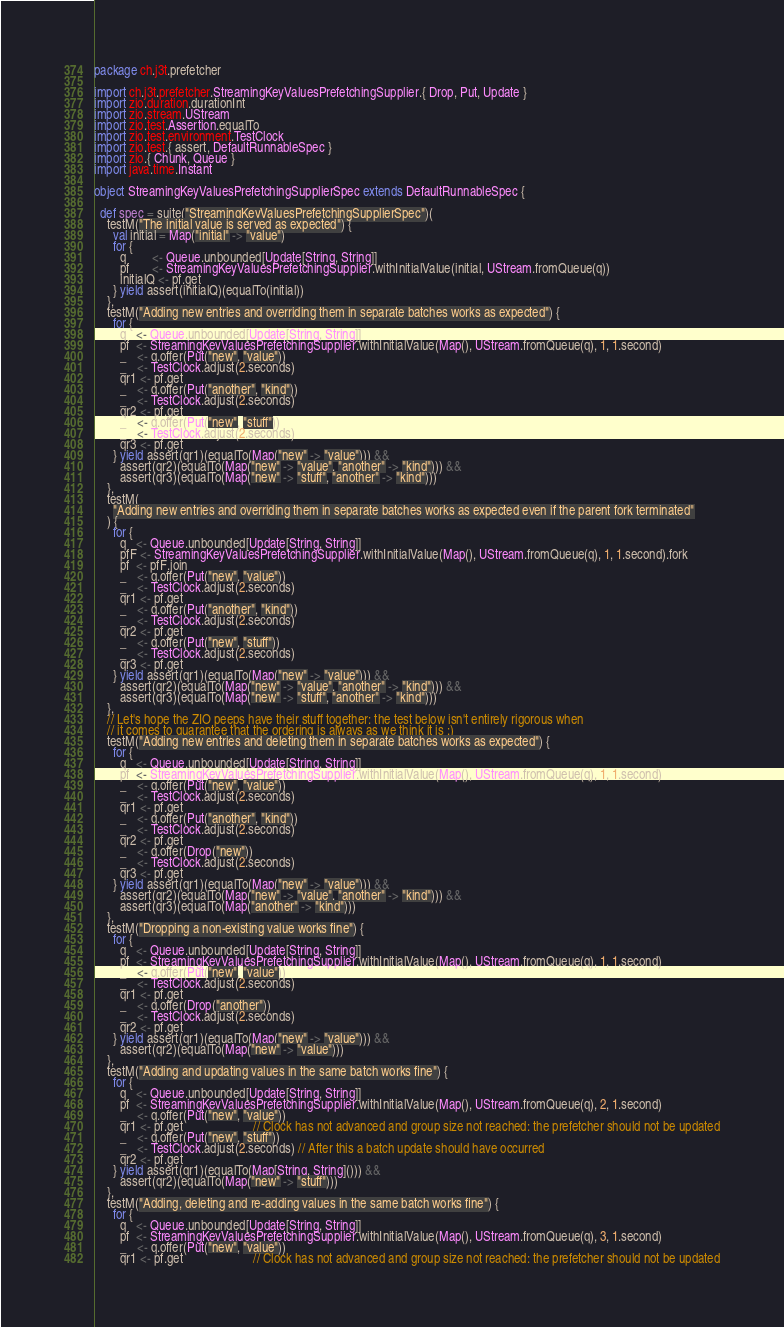Convert code to text. <code><loc_0><loc_0><loc_500><loc_500><_Scala_>package ch.j3t.prefetcher

import ch.j3t.prefetcher.StreamingKeyValuesPrefetchingSupplier.{ Drop, Put, Update }
import zio.duration.durationInt
import zio.stream.UStream
import zio.test.Assertion.equalTo
import zio.test.environment.TestClock
import zio.test.{ assert, DefaultRunnableSpec }
import zio.{ Chunk, Queue }
import java.time.Instant

object StreamingKeyValuesPrefetchingSupplierSpec extends DefaultRunnableSpec {

  def spec = suite("StreamingKeyValuesPrefetchingSupplierSpec")(
    testM("The initial value is served as expected") {
      val initial = Map("initial" -> "value")
      for {
        q        <- Queue.unbounded[Update[String, String]]
        pf       <- StreamingKeyValuesPrefetchingSupplier.withInitialValue(initial, UStream.fromQueue(q))
        initialQ <- pf.get
      } yield assert(initialQ)(equalTo(initial))
    },
    testM("Adding new entries and overriding them in separate batches works as expected") {
      for {
        q   <- Queue.unbounded[Update[String, String]]
        pf  <- StreamingKeyValuesPrefetchingSupplier.withInitialValue(Map(), UStream.fromQueue(q), 1, 1.second)
        _   <- q.offer(Put("new", "value"))
        _   <- TestClock.adjust(2.seconds)
        qr1 <- pf.get
        _   <- q.offer(Put("another", "kind"))
        _   <- TestClock.adjust(2.seconds)
        qr2 <- pf.get
        _   <- q.offer(Put("new", "stuff"))
        _   <- TestClock.adjust(2.seconds)
        qr3 <- pf.get
      } yield assert(qr1)(equalTo(Map("new" -> "value"))) &&
        assert(qr2)(equalTo(Map("new" -> "value", "another" -> "kind"))) &&
        assert(qr3)(equalTo(Map("new" -> "stuff", "another" -> "kind")))
    },
    testM(
      "Adding new entries and overriding them in separate batches works as expected even if the parent fork terminated"
    ) {
      for {
        q   <- Queue.unbounded[Update[String, String]]
        pfF <- StreamingKeyValuesPrefetchingSupplier.withInitialValue(Map(), UStream.fromQueue(q), 1, 1.second).fork
        pf  <- pfF.join
        _   <- q.offer(Put("new", "value"))
        _   <- TestClock.adjust(2.seconds)
        qr1 <- pf.get
        _   <- q.offer(Put("another", "kind"))
        _   <- TestClock.adjust(2.seconds)
        qr2 <- pf.get
        _   <- q.offer(Put("new", "stuff"))
        _   <- TestClock.adjust(2.seconds)
        qr3 <- pf.get
      } yield assert(qr1)(equalTo(Map("new" -> "value"))) &&
        assert(qr2)(equalTo(Map("new" -> "value", "another" -> "kind"))) &&
        assert(qr3)(equalTo(Map("new" -> "stuff", "another" -> "kind")))
    },
    // Let's hope the ZIO peeps have their stuff together: the test below isn't entirely rigorous when
    // it comes to guarantee that the ordering is always as we think it is ;)
    testM("Adding new entries and deleting them in separate batches works as expected") {
      for {
        q   <- Queue.unbounded[Update[String, String]]
        pf  <- StreamingKeyValuesPrefetchingSupplier.withInitialValue(Map(), UStream.fromQueue(q), 1, 1.second)
        _   <- q.offer(Put("new", "value"))
        _   <- TestClock.adjust(2.seconds)
        qr1 <- pf.get
        _   <- q.offer(Put("another", "kind"))
        _   <- TestClock.adjust(2.seconds)
        qr2 <- pf.get
        _   <- q.offer(Drop("new"))
        _   <- TestClock.adjust(2.seconds)
        qr3 <- pf.get
      } yield assert(qr1)(equalTo(Map("new" -> "value"))) &&
        assert(qr2)(equalTo(Map("new" -> "value", "another" -> "kind"))) &&
        assert(qr3)(equalTo(Map("another" -> "kind")))
    },
    testM("Dropping a non-existing value works fine") {
      for {
        q   <- Queue.unbounded[Update[String, String]]
        pf  <- StreamingKeyValuesPrefetchingSupplier.withInitialValue(Map(), UStream.fromQueue(q), 1, 1.second)
        _   <- q.offer(Put("new", "value"))
        _   <- TestClock.adjust(2.seconds)
        qr1 <- pf.get
        _   <- q.offer(Drop("another"))
        _   <- TestClock.adjust(2.seconds)
        qr2 <- pf.get
      } yield assert(qr1)(equalTo(Map("new" -> "value"))) &&
        assert(qr2)(equalTo(Map("new" -> "value")))
    },
    testM("Adding and updating values in the same batch works fine") {
      for {
        q   <- Queue.unbounded[Update[String, String]]
        pf  <- StreamingKeyValuesPrefetchingSupplier.withInitialValue(Map(), UStream.fromQueue(q), 2, 1.second)
        _   <- q.offer(Put("new", "value"))
        qr1 <- pf.get                      // Clock has not advanced and group size not reached: the prefetcher should not be updated
        _   <- q.offer(Put("new", "stuff"))
        _   <- TestClock.adjust(2.seconds) // After this a batch update should have occurred
        qr2 <- pf.get
      } yield assert(qr1)(equalTo(Map[String, String]())) &&
        assert(qr2)(equalTo(Map("new" -> "stuff")))
    },
    testM("Adding, deleting and re-adding values in the same batch works fine") {
      for {
        q   <- Queue.unbounded[Update[String, String]]
        pf  <- StreamingKeyValuesPrefetchingSupplier.withInitialValue(Map(), UStream.fromQueue(q), 3, 1.second)
        _   <- q.offer(Put("new", "value"))
        qr1 <- pf.get                      // Clock has not advanced and group size not reached: the prefetcher should not be updated</code> 